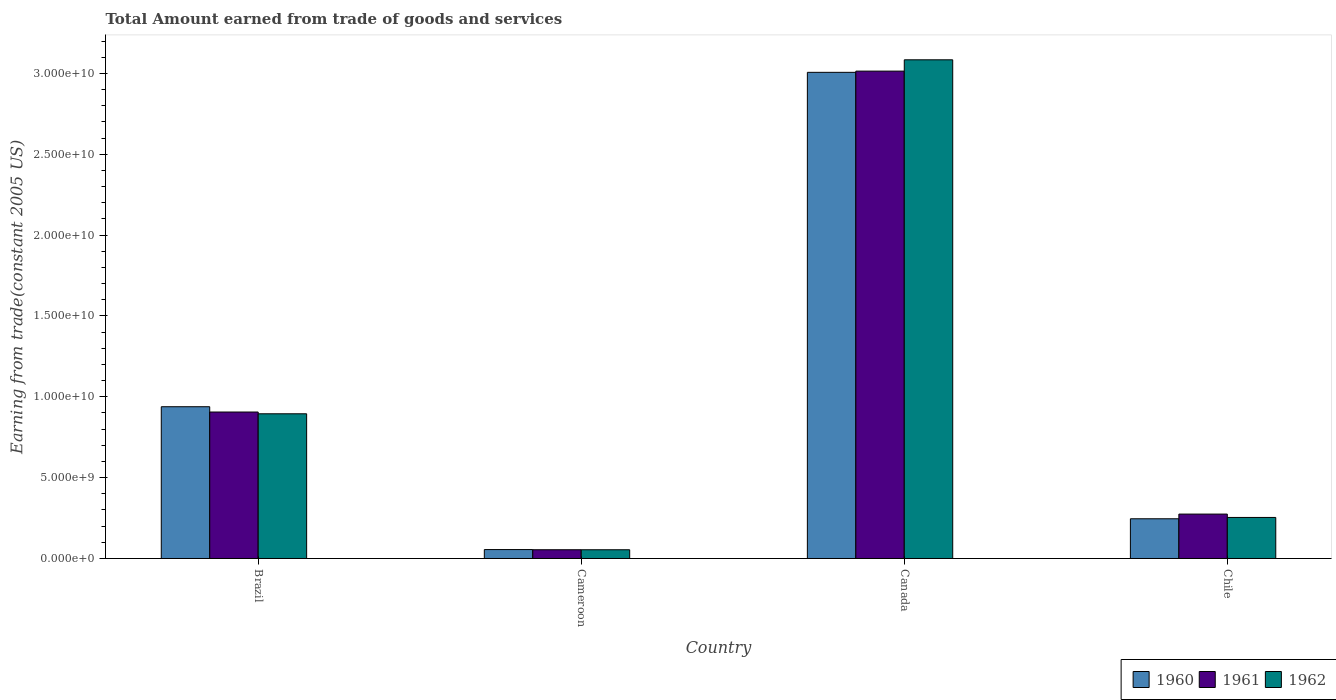How many different coloured bars are there?
Provide a short and direct response. 3. How many groups of bars are there?
Offer a very short reply. 4. Are the number of bars per tick equal to the number of legend labels?
Your response must be concise. Yes. How many bars are there on the 1st tick from the left?
Provide a short and direct response. 3. How many bars are there on the 4th tick from the right?
Provide a succinct answer. 3. What is the label of the 1st group of bars from the left?
Your answer should be compact. Brazil. In how many cases, is the number of bars for a given country not equal to the number of legend labels?
Your response must be concise. 0. What is the total amount earned by trading goods and services in 1960 in Canada?
Give a very brief answer. 3.01e+1. Across all countries, what is the maximum total amount earned by trading goods and services in 1961?
Offer a very short reply. 3.01e+1. Across all countries, what is the minimum total amount earned by trading goods and services in 1961?
Ensure brevity in your answer.  5.41e+08. In which country was the total amount earned by trading goods and services in 1962 minimum?
Provide a short and direct response. Cameroon. What is the total total amount earned by trading goods and services in 1962 in the graph?
Provide a short and direct response. 4.29e+1. What is the difference between the total amount earned by trading goods and services in 1960 in Brazil and that in Chile?
Your response must be concise. 6.93e+09. What is the difference between the total amount earned by trading goods and services in 1960 in Brazil and the total amount earned by trading goods and services in 1961 in Chile?
Give a very brief answer. 6.64e+09. What is the average total amount earned by trading goods and services in 1962 per country?
Ensure brevity in your answer.  1.07e+1. What is the difference between the total amount earned by trading goods and services of/in 1961 and total amount earned by trading goods and services of/in 1962 in Brazil?
Give a very brief answer. 1.09e+08. In how many countries, is the total amount earned by trading goods and services in 1960 greater than 8000000000 US$?
Your response must be concise. 2. What is the ratio of the total amount earned by trading goods and services in 1960 in Brazil to that in Chile?
Provide a succinct answer. 3.82. Is the total amount earned by trading goods and services in 1960 in Cameroon less than that in Canada?
Offer a very short reply. Yes. Is the difference between the total amount earned by trading goods and services in 1961 in Brazil and Canada greater than the difference between the total amount earned by trading goods and services in 1962 in Brazil and Canada?
Offer a terse response. Yes. What is the difference between the highest and the second highest total amount earned by trading goods and services in 1960?
Keep it short and to the point. -2.07e+1. What is the difference between the highest and the lowest total amount earned by trading goods and services in 1961?
Your answer should be very brief. 2.96e+1. Is the sum of the total amount earned by trading goods and services in 1960 in Brazil and Chile greater than the maximum total amount earned by trading goods and services in 1961 across all countries?
Your answer should be compact. No. What does the 1st bar from the left in Canada represents?
Give a very brief answer. 1960. What does the 2nd bar from the right in Canada represents?
Keep it short and to the point. 1961. How many bars are there?
Provide a short and direct response. 12. How many countries are there in the graph?
Offer a terse response. 4. Does the graph contain grids?
Your answer should be very brief. No. What is the title of the graph?
Your answer should be compact. Total Amount earned from trade of goods and services. Does "2008" appear as one of the legend labels in the graph?
Make the answer very short. No. What is the label or title of the Y-axis?
Keep it short and to the point. Earning from trade(constant 2005 US). What is the Earning from trade(constant 2005 US) of 1960 in Brazil?
Provide a succinct answer. 9.39e+09. What is the Earning from trade(constant 2005 US) in 1961 in Brazil?
Keep it short and to the point. 9.06e+09. What is the Earning from trade(constant 2005 US) in 1962 in Brazil?
Provide a short and direct response. 8.95e+09. What is the Earning from trade(constant 2005 US) in 1960 in Cameroon?
Offer a terse response. 5.52e+08. What is the Earning from trade(constant 2005 US) in 1961 in Cameroon?
Your answer should be compact. 5.41e+08. What is the Earning from trade(constant 2005 US) in 1962 in Cameroon?
Keep it short and to the point. 5.40e+08. What is the Earning from trade(constant 2005 US) in 1960 in Canada?
Your answer should be very brief. 3.01e+1. What is the Earning from trade(constant 2005 US) in 1961 in Canada?
Your answer should be very brief. 3.01e+1. What is the Earning from trade(constant 2005 US) of 1962 in Canada?
Give a very brief answer. 3.08e+1. What is the Earning from trade(constant 2005 US) of 1960 in Chile?
Your response must be concise. 2.46e+09. What is the Earning from trade(constant 2005 US) in 1961 in Chile?
Offer a very short reply. 2.75e+09. What is the Earning from trade(constant 2005 US) of 1962 in Chile?
Your answer should be compact. 2.54e+09. Across all countries, what is the maximum Earning from trade(constant 2005 US) of 1960?
Your answer should be compact. 3.01e+1. Across all countries, what is the maximum Earning from trade(constant 2005 US) of 1961?
Offer a terse response. 3.01e+1. Across all countries, what is the maximum Earning from trade(constant 2005 US) in 1962?
Keep it short and to the point. 3.08e+1. Across all countries, what is the minimum Earning from trade(constant 2005 US) of 1960?
Offer a very short reply. 5.52e+08. Across all countries, what is the minimum Earning from trade(constant 2005 US) in 1961?
Keep it short and to the point. 5.41e+08. Across all countries, what is the minimum Earning from trade(constant 2005 US) of 1962?
Give a very brief answer. 5.40e+08. What is the total Earning from trade(constant 2005 US) of 1960 in the graph?
Provide a succinct answer. 4.25e+1. What is the total Earning from trade(constant 2005 US) of 1961 in the graph?
Your response must be concise. 4.25e+1. What is the total Earning from trade(constant 2005 US) in 1962 in the graph?
Your answer should be compact. 4.29e+1. What is the difference between the Earning from trade(constant 2005 US) in 1960 in Brazil and that in Cameroon?
Make the answer very short. 8.83e+09. What is the difference between the Earning from trade(constant 2005 US) in 1961 in Brazil and that in Cameroon?
Keep it short and to the point. 8.52e+09. What is the difference between the Earning from trade(constant 2005 US) of 1962 in Brazil and that in Cameroon?
Your response must be concise. 8.41e+09. What is the difference between the Earning from trade(constant 2005 US) in 1960 in Brazil and that in Canada?
Your response must be concise. -2.07e+1. What is the difference between the Earning from trade(constant 2005 US) in 1961 in Brazil and that in Canada?
Make the answer very short. -2.11e+1. What is the difference between the Earning from trade(constant 2005 US) in 1962 in Brazil and that in Canada?
Keep it short and to the point. -2.19e+1. What is the difference between the Earning from trade(constant 2005 US) in 1960 in Brazil and that in Chile?
Your answer should be compact. 6.93e+09. What is the difference between the Earning from trade(constant 2005 US) in 1961 in Brazil and that in Chile?
Keep it short and to the point. 6.31e+09. What is the difference between the Earning from trade(constant 2005 US) of 1962 in Brazil and that in Chile?
Your answer should be very brief. 6.41e+09. What is the difference between the Earning from trade(constant 2005 US) in 1960 in Cameroon and that in Canada?
Your response must be concise. -2.95e+1. What is the difference between the Earning from trade(constant 2005 US) of 1961 in Cameroon and that in Canada?
Make the answer very short. -2.96e+1. What is the difference between the Earning from trade(constant 2005 US) in 1962 in Cameroon and that in Canada?
Your response must be concise. -3.03e+1. What is the difference between the Earning from trade(constant 2005 US) of 1960 in Cameroon and that in Chile?
Your answer should be very brief. -1.90e+09. What is the difference between the Earning from trade(constant 2005 US) of 1961 in Cameroon and that in Chile?
Give a very brief answer. -2.21e+09. What is the difference between the Earning from trade(constant 2005 US) of 1962 in Cameroon and that in Chile?
Provide a short and direct response. -2.00e+09. What is the difference between the Earning from trade(constant 2005 US) in 1960 in Canada and that in Chile?
Your answer should be very brief. 2.76e+1. What is the difference between the Earning from trade(constant 2005 US) in 1961 in Canada and that in Chile?
Offer a very short reply. 2.74e+1. What is the difference between the Earning from trade(constant 2005 US) of 1962 in Canada and that in Chile?
Keep it short and to the point. 2.83e+1. What is the difference between the Earning from trade(constant 2005 US) in 1960 in Brazil and the Earning from trade(constant 2005 US) in 1961 in Cameroon?
Offer a very short reply. 8.84e+09. What is the difference between the Earning from trade(constant 2005 US) in 1960 in Brazil and the Earning from trade(constant 2005 US) in 1962 in Cameroon?
Offer a terse response. 8.85e+09. What is the difference between the Earning from trade(constant 2005 US) in 1961 in Brazil and the Earning from trade(constant 2005 US) in 1962 in Cameroon?
Give a very brief answer. 8.52e+09. What is the difference between the Earning from trade(constant 2005 US) in 1960 in Brazil and the Earning from trade(constant 2005 US) in 1961 in Canada?
Make the answer very short. -2.08e+1. What is the difference between the Earning from trade(constant 2005 US) of 1960 in Brazil and the Earning from trade(constant 2005 US) of 1962 in Canada?
Your answer should be very brief. -2.15e+1. What is the difference between the Earning from trade(constant 2005 US) in 1961 in Brazil and the Earning from trade(constant 2005 US) in 1962 in Canada?
Keep it short and to the point. -2.18e+1. What is the difference between the Earning from trade(constant 2005 US) of 1960 in Brazil and the Earning from trade(constant 2005 US) of 1961 in Chile?
Your answer should be compact. 6.64e+09. What is the difference between the Earning from trade(constant 2005 US) in 1960 in Brazil and the Earning from trade(constant 2005 US) in 1962 in Chile?
Ensure brevity in your answer.  6.85e+09. What is the difference between the Earning from trade(constant 2005 US) of 1961 in Brazil and the Earning from trade(constant 2005 US) of 1962 in Chile?
Provide a succinct answer. 6.52e+09. What is the difference between the Earning from trade(constant 2005 US) in 1960 in Cameroon and the Earning from trade(constant 2005 US) in 1961 in Canada?
Provide a short and direct response. -2.96e+1. What is the difference between the Earning from trade(constant 2005 US) in 1960 in Cameroon and the Earning from trade(constant 2005 US) in 1962 in Canada?
Your answer should be very brief. -3.03e+1. What is the difference between the Earning from trade(constant 2005 US) of 1961 in Cameroon and the Earning from trade(constant 2005 US) of 1962 in Canada?
Provide a succinct answer. -3.03e+1. What is the difference between the Earning from trade(constant 2005 US) of 1960 in Cameroon and the Earning from trade(constant 2005 US) of 1961 in Chile?
Provide a succinct answer. -2.19e+09. What is the difference between the Earning from trade(constant 2005 US) of 1960 in Cameroon and the Earning from trade(constant 2005 US) of 1962 in Chile?
Your answer should be compact. -1.99e+09. What is the difference between the Earning from trade(constant 2005 US) of 1961 in Cameroon and the Earning from trade(constant 2005 US) of 1962 in Chile?
Provide a short and direct response. -2.00e+09. What is the difference between the Earning from trade(constant 2005 US) in 1960 in Canada and the Earning from trade(constant 2005 US) in 1961 in Chile?
Your answer should be compact. 2.73e+1. What is the difference between the Earning from trade(constant 2005 US) of 1960 in Canada and the Earning from trade(constant 2005 US) of 1962 in Chile?
Make the answer very short. 2.75e+1. What is the difference between the Earning from trade(constant 2005 US) in 1961 in Canada and the Earning from trade(constant 2005 US) in 1962 in Chile?
Your answer should be very brief. 2.76e+1. What is the average Earning from trade(constant 2005 US) of 1960 per country?
Your answer should be very brief. 1.06e+1. What is the average Earning from trade(constant 2005 US) of 1961 per country?
Offer a terse response. 1.06e+1. What is the average Earning from trade(constant 2005 US) in 1962 per country?
Your answer should be very brief. 1.07e+1. What is the difference between the Earning from trade(constant 2005 US) in 1960 and Earning from trade(constant 2005 US) in 1961 in Brazil?
Your answer should be compact. 3.27e+08. What is the difference between the Earning from trade(constant 2005 US) in 1960 and Earning from trade(constant 2005 US) in 1962 in Brazil?
Your answer should be compact. 4.36e+08. What is the difference between the Earning from trade(constant 2005 US) in 1961 and Earning from trade(constant 2005 US) in 1962 in Brazil?
Give a very brief answer. 1.09e+08. What is the difference between the Earning from trade(constant 2005 US) of 1960 and Earning from trade(constant 2005 US) of 1961 in Cameroon?
Offer a very short reply. 1.04e+07. What is the difference between the Earning from trade(constant 2005 US) in 1960 and Earning from trade(constant 2005 US) in 1962 in Cameroon?
Your answer should be compact. 1.17e+07. What is the difference between the Earning from trade(constant 2005 US) in 1961 and Earning from trade(constant 2005 US) in 1962 in Cameroon?
Make the answer very short. 1.36e+06. What is the difference between the Earning from trade(constant 2005 US) in 1960 and Earning from trade(constant 2005 US) in 1961 in Canada?
Your answer should be compact. -7.60e+07. What is the difference between the Earning from trade(constant 2005 US) in 1960 and Earning from trade(constant 2005 US) in 1962 in Canada?
Your answer should be very brief. -7.75e+08. What is the difference between the Earning from trade(constant 2005 US) of 1961 and Earning from trade(constant 2005 US) of 1962 in Canada?
Ensure brevity in your answer.  -6.99e+08. What is the difference between the Earning from trade(constant 2005 US) of 1960 and Earning from trade(constant 2005 US) of 1961 in Chile?
Give a very brief answer. -2.90e+08. What is the difference between the Earning from trade(constant 2005 US) in 1960 and Earning from trade(constant 2005 US) in 1962 in Chile?
Your answer should be compact. -8.15e+07. What is the difference between the Earning from trade(constant 2005 US) in 1961 and Earning from trade(constant 2005 US) in 1962 in Chile?
Provide a short and direct response. 2.09e+08. What is the ratio of the Earning from trade(constant 2005 US) of 1960 in Brazil to that in Cameroon?
Provide a short and direct response. 17.01. What is the ratio of the Earning from trade(constant 2005 US) in 1961 in Brazil to that in Cameroon?
Offer a very short reply. 16.73. What is the ratio of the Earning from trade(constant 2005 US) in 1962 in Brazil to that in Cameroon?
Give a very brief answer. 16.57. What is the ratio of the Earning from trade(constant 2005 US) of 1960 in Brazil to that in Canada?
Your answer should be very brief. 0.31. What is the ratio of the Earning from trade(constant 2005 US) in 1961 in Brazil to that in Canada?
Your answer should be compact. 0.3. What is the ratio of the Earning from trade(constant 2005 US) in 1962 in Brazil to that in Canada?
Give a very brief answer. 0.29. What is the ratio of the Earning from trade(constant 2005 US) of 1960 in Brazil to that in Chile?
Keep it short and to the point. 3.82. What is the ratio of the Earning from trade(constant 2005 US) in 1961 in Brazil to that in Chile?
Your answer should be very brief. 3.3. What is the ratio of the Earning from trade(constant 2005 US) of 1962 in Brazil to that in Chile?
Keep it short and to the point. 3.53. What is the ratio of the Earning from trade(constant 2005 US) in 1960 in Cameroon to that in Canada?
Make the answer very short. 0.02. What is the ratio of the Earning from trade(constant 2005 US) of 1961 in Cameroon to that in Canada?
Provide a short and direct response. 0.02. What is the ratio of the Earning from trade(constant 2005 US) in 1962 in Cameroon to that in Canada?
Give a very brief answer. 0.02. What is the ratio of the Earning from trade(constant 2005 US) of 1960 in Cameroon to that in Chile?
Your answer should be compact. 0.22. What is the ratio of the Earning from trade(constant 2005 US) of 1961 in Cameroon to that in Chile?
Your answer should be compact. 0.2. What is the ratio of the Earning from trade(constant 2005 US) of 1962 in Cameroon to that in Chile?
Your response must be concise. 0.21. What is the ratio of the Earning from trade(constant 2005 US) in 1960 in Canada to that in Chile?
Provide a short and direct response. 12.24. What is the ratio of the Earning from trade(constant 2005 US) in 1961 in Canada to that in Chile?
Make the answer very short. 10.97. What is the ratio of the Earning from trade(constant 2005 US) in 1962 in Canada to that in Chile?
Give a very brief answer. 12.15. What is the difference between the highest and the second highest Earning from trade(constant 2005 US) of 1960?
Ensure brevity in your answer.  2.07e+1. What is the difference between the highest and the second highest Earning from trade(constant 2005 US) of 1961?
Make the answer very short. 2.11e+1. What is the difference between the highest and the second highest Earning from trade(constant 2005 US) of 1962?
Give a very brief answer. 2.19e+1. What is the difference between the highest and the lowest Earning from trade(constant 2005 US) in 1960?
Your answer should be compact. 2.95e+1. What is the difference between the highest and the lowest Earning from trade(constant 2005 US) of 1961?
Your response must be concise. 2.96e+1. What is the difference between the highest and the lowest Earning from trade(constant 2005 US) of 1962?
Offer a very short reply. 3.03e+1. 